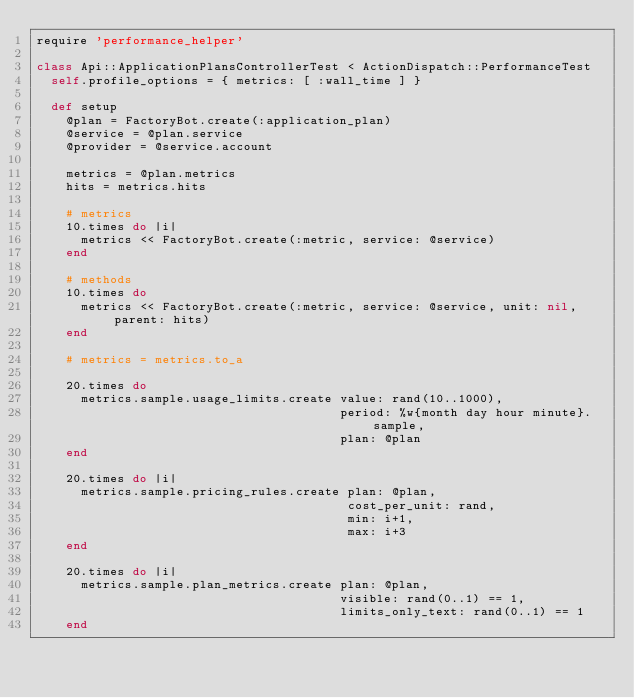<code> <loc_0><loc_0><loc_500><loc_500><_Ruby_>require 'performance_helper'

class Api::ApplicationPlansControllerTest < ActionDispatch::PerformanceTest
  self.profile_options = { metrics: [ :wall_time ] }

  def setup
    @plan = FactoryBot.create(:application_plan)
    @service = @plan.service
    @provider = @service.account

    metrics = @plan.metrics
    hits = metrics.hits

    # metrics
    10.times do |i|
      metrics << FactoryBot.create(:metric, service: @service)
    end

    # methods
    10.times do
      metrics << FactoryBot.create(:metric, service: @service, unit: nil, parent: hits)
    end

    # metrics = metrics.to_a

    20.times do
      metrics.sample.usage_limits.create value: rand(10..1000),
                                         period: %w{month day hour minute}.sample,
                                         plan: @plan
    end

    20.times do |i|
      metrics.sample.pricing_rules.create plan: @plan,
                                          cost_per_unit: rand,
                                          min: i+1,
                                          max: i+3
    end

    20.times do |i|
      metrics.sample.plan_metrics.create plan: @plan,
                                         visible: rand(0..1) == 1,
                                         limits_only_text: rand(0..1) == 1
    end
</code> 